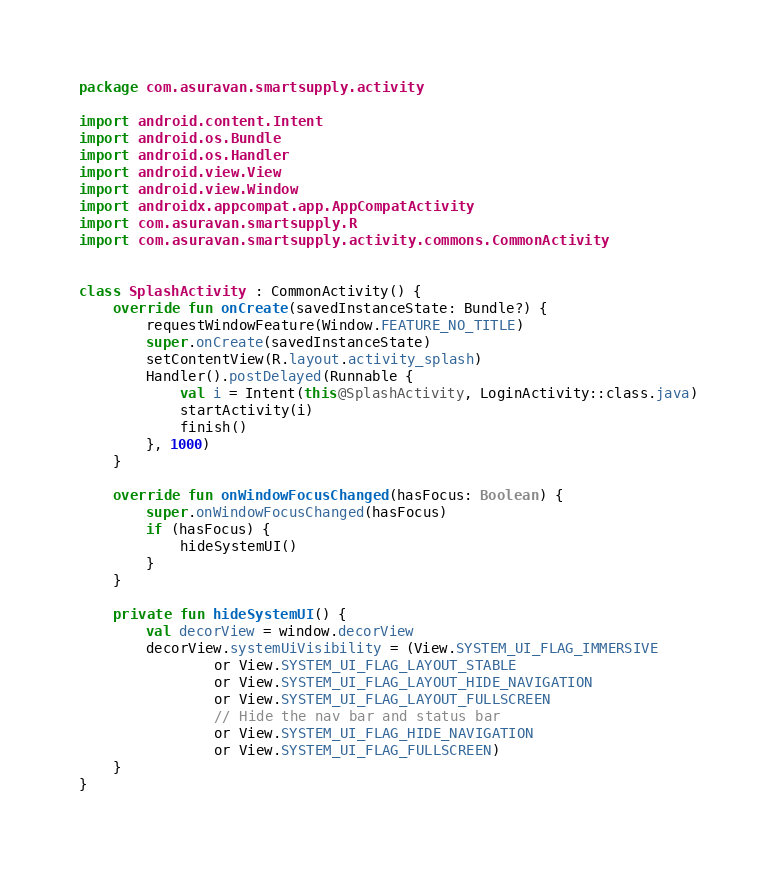<code> <loc_0><loc_0><loc_500><loc_500><_Kotlin_>package com.asuravan.smartsupply.activity

import android.content.Intent
import android.os.Bundle
import android.os.Handler
import android.view.View
import android.view.Window
import androidx.appcompat.app.AppCompatActivity
import com.asuravan.smartsupply.R
import com.asuravan.smartsupply.activity.commons.CommonActivity


class SplashActivity : CommonActivity() {
    override fun onCreate(savedInstanceState: Bundle?) {
        requestWindowFeature(Window.FEATURE_NO_TITLE)
        super.onCreate(savedInstanceState)
        setContentView(R.layout.activity_splash)
        Handler().postDelayed(Runnable {
            val i = Intent(this@SplashActivity, LoginActivity::class.java)
            startActivity(i)
            finish()
        }, 1000)
    }

    override fun onWindowFocusChanged(hasFocus: Boolean) {
        super.onWindowFocusChanged(hasFocus)
        if (hasFocus) {
            hideSystemUI()
        }
    }

    private fun hideSystemUI() {
        val decorView = window.decorView
        decorView.systemUiVisibility = (View.SYSTEM_UI_FLAG_IMMERSIVE
                or View.SYSTEM_UI_FLAG_LAYOUT_STABLE
                or View.SYSTEM_UI_FLAG_LAYOUT_HIDE_NAVIGATION
                or View.SYSTEM_UI_FLAG_LAYOUT_FULLSCREEN
                // Hide the nav bar and status bar
                or View.SYSTEM_UI_FLAG_HIDE_NAVIGATION
                or View.SYSTEM_UI_FLAG_FULLSCREEN)
    }
}</code> 